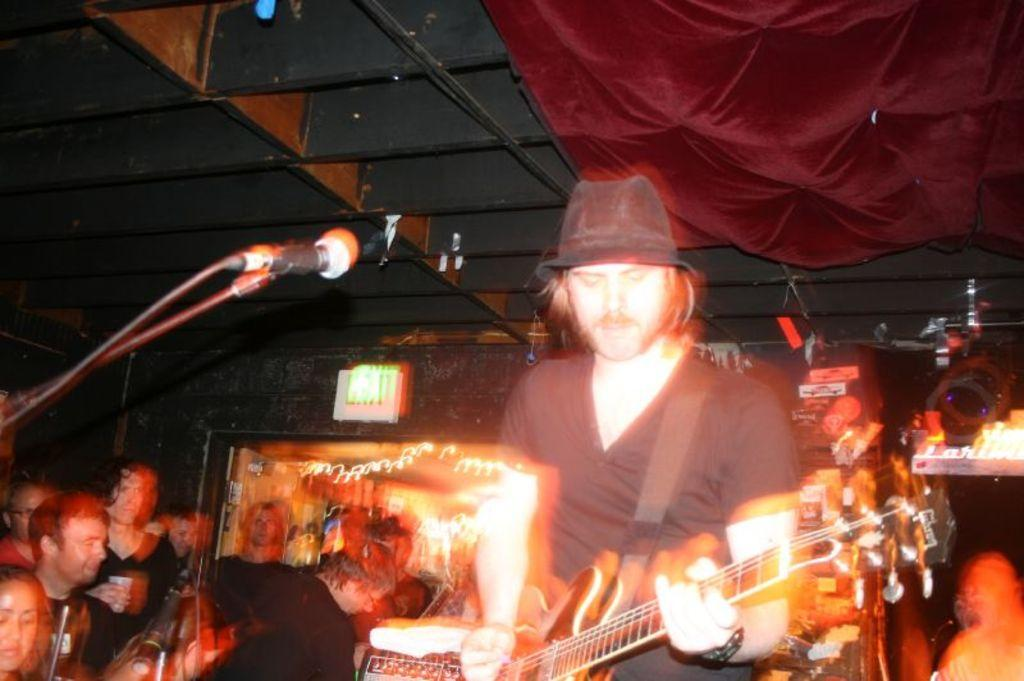Who is the main subject in the image? There is a man in the image. What is the man holding in the image? The man is holding a guitar. What is the man positioned in front of in the image? The man is in front of a microphone. Can you describe the people in the background of the image? There are people in the background of the image, but their specific actions or features are not mentioned in the provided facts. What language is the boy speaking in the image? There is no boy present in the image, and therefore no language can be attributed to him. 